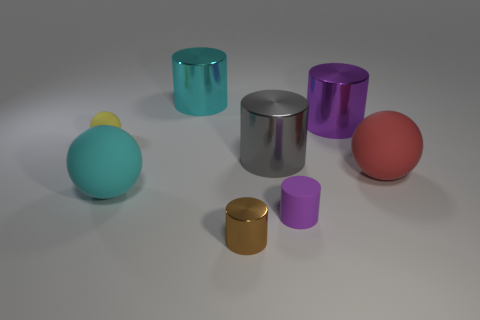What can we infer about the lighting setup from the shadows and reflections in the image? The shadows cast are soft and diffuse, suggesting the presence of a broad, non-directional light source, likely positioned above the scene. This ample lighting results in gentle reflections and a minimal contrast between light and shadow, which contributes to the image's calm and balanced ambiance. 